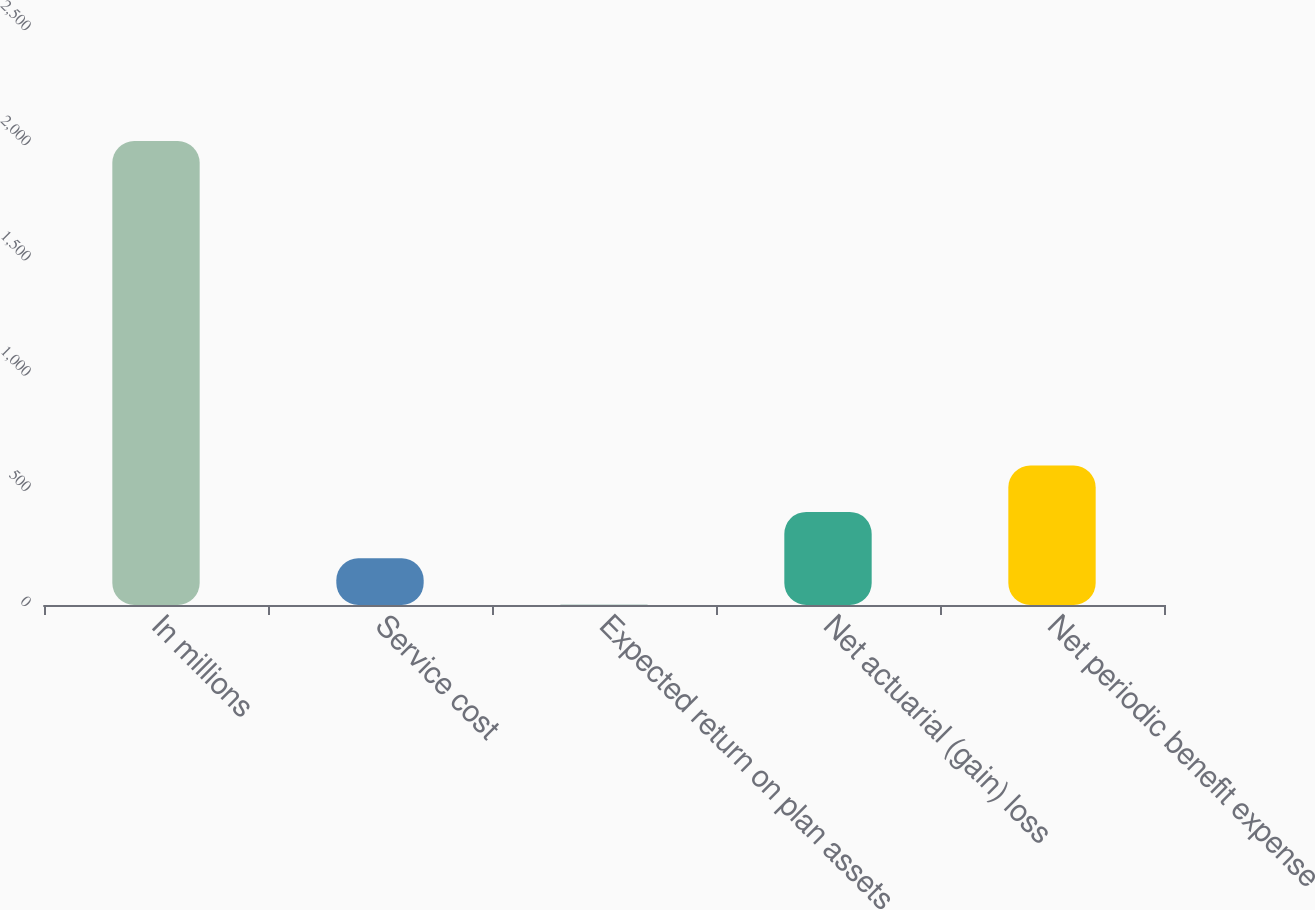<chart> <loc_0><loc_0><loc_500><loc_500><bar_chart><fcel>In millions<fcel>Service cost<fcel>Expected return on plan assets<fcel>Net actuarial (gain) loss<fcel>Net periodic benefit expense<nl><fcel>2014<fcel>202.93<fcel>1.7<fcel>404.16<fcel>605.39<nl></chart> 